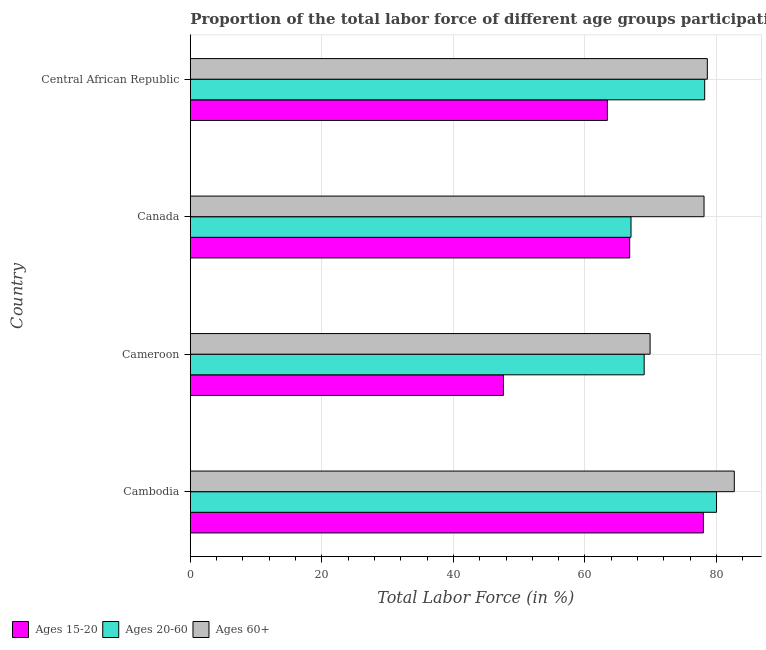How many different coloured bars are there?
Ensure brevity in your answer.  3. Are the number of bars on each tick of the Y-axis equal?
Your answer should be very brief. Yes. How many bars are there on the 3rd tick from the top?
Provide a succinct answer. 3. What is the label of the 4th group of bars from the top?
Keep it short and to the point. Cambodia. In how many cases, is the number of bars for a given country not equal to the number of legend labels?
Ensure brevity in your answer.  0. What is the percentage of labor force within the age group 15-20 in Cameroon?
Make the answer very short. 47.6. Across all countries, what is the maximum percentage of labor force within the age group 20-60?
Give a very brief answer. 80. In which country was the percentage of labor force within the age group 20-60 maximum?
Your answer should be compact. Cambodia. In which country was the percentage of labor force above age 60 minimum?
Provide a succinct answer. Cameroon. What is the total percentage of labor force within the age group 20-60 in the graph?
Your response must be concise. 294.2. What is the difference between the percentage of labor force within the age group 20-60 in Canada and that in Central African Republic?
Make the answer very short. -11.2. What is the difference between the percentage of labor force above age 60 in Cameroon and the percentage of labor force within the age group 15-20 in Cambodia?
Provide a short and direct response. -8.1. What is the average percentage of labor force within the age group 15-20 per country?
Offer a very short reply. 63.95. In how many countries, is the percentage of labor force within the age group 15-20 greater than 4 %?
Provide a short and direct response. 4. What is the ratio of the percentage of labor force within the age group 15-20 in Cambodia to that in Central African Republic?
Provide a succinct answer. 1.23. Is the percentage of labor force within the age group 20-60 in Cambodia less than that in Central African Republic?
Offer a terse response. No. Is the difference between the percentage of labor force within the age group 15-20 in Cambodia and Cameroon greater than the difference between the percentage of labor force above age 60 in Cambodia and Cameroon?
Your answer should be very brief. Yes. What is the difference between the highest and the lowest percentage of labor force above age 60?
Offer a very short reply. 12.8. In how many countries, is the percentage of labor force within the age group 20-60 greater than the average percentage of labor force within the age group 20-60 taken over all countries?
Your response must be concise. 2. What does the 1st bar from the top in Central African Republic represents?
Keep it short and to the point. Ages 60+. What does the 2nd bar from the bottom in Cambodia represents?
Provide a short and direct response. Ages 20-60. Is it the case that in every country, the sum of the percentage of labor force within the age group 15-20 and percentage of labor force within the age group 20-60 is greater than the percentage of labor force above age 60?
Your answer should be very brief. Yes. How many bars are there?
Your answer should be very brief. 12. Are all the bars in the graph horizontal?
Your answer should be very brief. Yes. What is the difference between two consecutive major ticks on the X-axis?
Your response must be concise. 20. Are the values on the major ticks of X-axis written in scientific E-notation?
Provide a short and direct response. No. Does the graph contain any zero values?
Give a very brief answer. No. How are the legend labels stacked?
Give a very brief answer. Horizontal. What is the title of the graph?
Offer a terse response. Proportion of the total labor force of different age groups participating in production in 2004. Does "Taxes on goods and services" appear as one of the legend labels in the graph?
Your answer should be very brief. No. What is the label or title of the X-axis?
Ensure brevity in your answer.  Total Labor Force (in %). What is the Total Labor Force (in %) of Ages 15-20 in Cambodia?
Make the answer very short. 78. What is the Total Labor Force (in %) of Ages 20-60 in Cambodia?
Offer a terse response. 80. What is the Total Labor Force (in %) in Ages 60+ in Cambodia?
Provide a short and direct response. 82.7. What is the Total Labor Force (in %) of Ages 15-20 in Cameroon?
Provide a succinct answer. 47.6. What is the Total Labor Force (in %) in Ages 60+ in Cameroon?
Your answer should be very brief. 69.9. What is the Total Labor Force (in %) of Ages 15-20 in Canada?
Your response must be concise. 66.8. What is the Total Labor Force (in %) of Ages 60+ in Canada?
Your answer should be compact. 78.1. What is the Total Labor Force (in %) of Ages 15-20 in Central African Republic?
Offer a very short reply. 63.4. What is the Total Labor Force (in %) in Ages 20-60 in Central African Republic?
Ensure brevity in your answer.  78.2. What is the Total Labor Force (in %) in Ages 60+ in Central African Republic?
Give a very brief answer. 78.6. Across all countries, what is the maximum Total Labor Force (in %) of Ages 20-60?
Offer a terse response. 80. Across all countries, what is the maximum Total Labor Force (in %) of Ages 60+?
Provide a succinct answer. 82.7. Across all countries, what is the minimum Total Labor Force (in %) of Ages 15-20?
Your response must be concise. 47.6. Across all countries, what is the minimum Total Labor Force (in %) of Ages 20-60?
Give a very brief answer. 67. Across all countries, what is the minimum Total Labor Force (in %) of Ages 60+?
Keep it short and to the point. 69.9. What is the total Total Labor Force (in %) of Ages 15-20 in the graph?
Provide a succinct answer. 255.8. What is the total Total Labor Force (in %) of Ages 20-60 in the graph?
Keep it short and to the point. 294.2. What is the total Total Labor Force (in %) of Ages 60+ in the graph?
Offer a terse response. 309.3. What is the difference between the Total Labor Force (in %) in Ages 15-20 in Cambodia and that in Cameroon?
Offer a very short reply. 30.4. What is the difference between the Total Labor Force (in %) of Ages 20-60 in Cambodia and that in Cameroon?
Offer a very short reply. 11. What is the difference between the Total Labor Force (in %) in Ages 20-60 in Cambodia and that in Canada?
Provide a succinct answer. 13. What is the difference between the Total Labor Force (in %) of Ages 60+ in Cambodia and that in Canada?
Offer a terse response. 4.6. What is the difference between the Total Labor Force (in %) of Ages 15-20 in Cambodia and that in Central African Republic?
Your answer should be compact. 14.6. What is the difference between the Total Labor Force (in %) of Ages 20-60 in Cambodia and that in Central African Republic?
Keep it short and to the point. 1.8. What is the difference between the Total Labor Force (in %) of Ages 15-20 in Cameroon and that in Canada?
Offer a very short reply. -19.2. What is the difference between the Total Labor Force (in %) of Ages 20-60 in Cameroon and that in Canada?
Keep it short and to the point. 2. What is the difference between the Total Labor Force (in %) in Ages 60+ in Cameroon and that in Canada?
Provide a succinct answer. -8.2. What is the difference between the Total Labor Force (in %) in Ages 15-20 in Cameroon and that in Central African Republic?
Provide a short and direct response. -15.8. What is the difference between the Total Labor Force (in %) in Ages 20-60 in Cameroon and that in Central African Republic?
Offer a terse response. -9.2. What is the difference between the Total Labor Force (in %) in Ages 60+ in Cameroon and that in Central African Republic?
Offer a terse response. -8.7. What is the difference between the Total Labor Force (in %) in Ages 15-20 in Canada and that in Central African Republic?
Your answer should be compact. 3.4. What is the difference between the Total Labor Force (in %) of Ages 20-60 in Canada and that in Central African Republic?
Keep it short and to the point. -11.2. What is the difference between the Total Labor Force (in %) in Ages 15-20 in Cambodia and the Total Labor Force (in %) in Ages 20-60 in Cameroon?
Give a very brief answer. 9. What is the difference between the Total Labor Force (in %) in Ages 15-20 in Cambodia and the Total Labor Force (in %) in Ages 60+ in Cameroon?
Your answer should be compact. 8.1. What is the difference between the Total Labor Force (in %) of Ages 15-20 in Cambodia and the Total Labor Force (in %) of Ages 60+ in Canada?
Your answer should be compact. -0.1. What is the difference between the Total Labor Force (in %) in Ages 20-60 in Cambodia and the Total Labor Force (in %) in Ages 60+ in Canada?
Your answer should be very brief. 1.9. What is the difference between the Total Labor Force (in %) of Ages 15-20 in Cambodia and the Total Labor Force (in %) of Ages 20-60 in Central African Republic?
Keep it short and to the point. -0.2. What is the difference between the Total Labor Force (in %) of Ages 20-60 in Cambodia and the Total Labor Force (in %) of Ages 60+ in Central African Republic?
Ensure brevity in your answer.  1.4. What is the difference between the Total Labor Force (in %) in Ages 15-20 in Cameroon and the Total Labor Force (in %) in Ages 20-60 in Canada?
Your response must be concise. -19.4. What is the difference between the Total Labor Force (in %) in Ages 15-20 in Cameroon and the Total Labor Force (in %) in Ages 60+ in Canada?
Give a very brief answer. -30.5. What is the difference between the Total Labor Force (in %) of Ages 15-20 in Cameroon and the Total Labor Force (in %) of Ages 20-60 in Central African Republic?
Offer a terse response. -30.6. What is the difference between the Total Labor Force (in %) of Ages 15-20 in Cameroon and the Total Labor Force (in %) of Ages 60+ in Central African Republic?
Make the answer very short. -31. What is the difference between the Total Labor Force (in %) of Ages 15-20 in Canada and the Total Labor Force (in %) of Ages 20-60 in Central African Republic?
Provide a short and direct response. -11.4. What is the difference between the Total Labor Force (in %) in Ages 15-20 in Canada and the Total Labor Force (in %) in Ages 60+ in Central African Republic?
Your response must be concise. -11.8. What is the average Total Labor Force (in %) in Ages 15-20 per country?
Make the answer very short. 63.95. What is the average Total Labor Force (in %) in Ages 20-60 per country?
Make the answer very short. 73.55. What is the average Total Labor Force (in %) of Ages 60+ per country?
Offer a terse response. 77.33. What is the difference between the Total Labor Force (in %) of Ages 15-20 and Total Labor Force (in %) of Ages 20-60 in Cambodia?
Provide a succinct answer. -2. What is the difference between the Total Labor Force (in %) of Ages 20-60 and Total Labor Force (in %) of Ages 60+ in Cambodia?
Give a very brief answer. -2.7. What is the difference between the Total Labor Force (in %) in Ages 15-20 and Total Labor Force (in %) in Ages 20-60 in Cameroon?
Provide a short and direct response. -21.4. What is the difference between the Total Labor Force (in %) in Ages 15-20 and Total Labor Force (in %) in Ages 60+ in Cameroon?
Your answer should be compact. -22.3. What is the difference between the Total Labor Force (in %) of Ages 15-20 and Total Labor Force (in %) of Ages 20-60 in Canada?
Make the answer very short. -0.2. What is the difference between the Total Labor Force (in %) in Ages 15-20 and Total Labor Force (in %) in Ages 60+ in Canada?
Your response must be concise. -11.3. What is the difference between the Total Labor Force (in %) of Ages 20-60 and Total Labor Force (in %) of Ages 60+ in Canada?
Your answer should be very brief. -11.1. What is the difference between the Total Labor Force (in %) of Ages 15-20 and Total Labor Force (in %) of Ages 20-60 in Central African Republic?
Provide a short and direct response. -14.8. What is the difference between the Total Labor Force (in %) of Ages 15-20 and Total Labor Force (in %) of Ages 60+ in Central African Republic?
Give a very brief answer. -15.2. What is the difference between the Total Labor Force (in %) in Ages 20-60 and Total Labor Force (in %) in Ages 60+ in Central African Republic?
Your response must be concise. -0.4. What is the ratio of the Total Labor Force (in %) in Ages 15-20 in Cambodia to that in Cameroon?
Provide a succinct answer. 1.64. What is the ratio of the Total Labor Force (in %) in Ages 20-60 in Cambodia to that in Cameroon?
Make the answer very short. 1.16. What is the ratio of the Total Labor Force (in %) in Ages 60+ in Cambodia to that in Cameroon?
Offer a very short reply. 1.18. What is the ratio of the Total Labor Force (in %) of Ages 15-20 in Cambodia to that in Canada?
Provide a short and direct response. 1.17. What is the ratio of the Total Labor Force (in %) in Ages 20-60 in Cambodia to that in Canada?
Keep it short and to the point. 1.19. What is the ratio of the Total Labor Force (in %) in Ages 60+ in Cambodia to that in Canada?
Make the answer very short. 1.06. What is the ratio of the Total Labor Force (in %) in Ages 15-20 in Cambodia to that in Central African Republic?
Provide a short and direct response. 1.23. What is the ratio of the Total Labor Force (in %) of Ages 60+ in Cambodia to that in Central African Republic?
Your answer should be compact. 1.05. What is the ratio of the Total Labor Force (in %) in Ages 15-20 in Cameroon to that in Canada?
Offer a terse response. 0.71. What is the ratio of the Total Labor Force (in %) in Ages 20-60 in Cameroon to that in Canada?
Provide a succinct answer. 1.03. What is the ratio of the Total Labor Force (in %) of Ages 60+ in Cameroon to that in Canada?
Keep it short and to the point. 0.9. What is the ratio of the Total Labor Force (in %) in Ages 15-20 in Cameroon to that in Central African Republic?
Ensure brevity in your answer.  0.75. What is the ratio of the Total Labor Force (in %) in Ages 20-60 in Cameroon to that in Central African Republic?
Ensure brevity in your answer.  0.88. What is the ratio of the Total Labor Force (in %) of Ages 60+ in Cameroon to that in Central African Republic?
Offer a terse response. 0.89. What is the ratio of the Total Labor Force (in %) of Ages 15-20 in Canada to that in Central African Republic?
Your answer should be compact. 1.05. What is the ratio of the Total Labor Force (in %) of Ages 20-60 in Canada to that in Central African Republic?
Make the answer very short. 0.86. What is the ratio of the Total Labor Force (in %) in Ages 60+ in Canada to that in Central African Republic?
Make the answer very short. 0.99. What is the difference between the highest and the second highest Total Labor Force (in %) in Ages 20-60?
Offer a very short reply. 1.8. What is the difference between the highest and the second highest Total Labor Force (in %) of Ages 60+?
Your response must be concise. 4.1. What is the difference between the highest and the lowest Total Labor Force (in %) in Ages 15-20?
Provide a short and direct response. 30.4. What is the difference between the highest and the lowest Total Labor Force (in %) of Ages 20-60?
Your answer should be compact. 13. What is the difference between the highest and the lowest Total Labor Force (in %) of Ages 60+?
Make the answer very short. 12.8. 